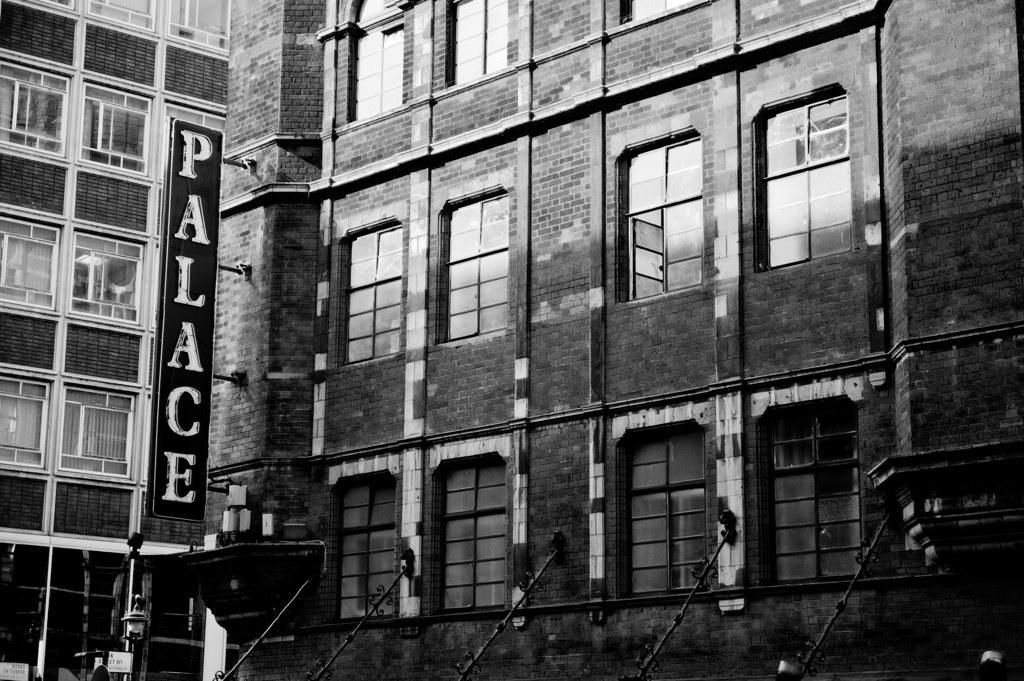What is the color scheme of the image? The image is black and white. What type of structure can be seen in the image? There is a building in the image. Where is the board located in the image? The board is on the left side of the image. How many lizards are crawling on the building in the image? There are no lizards present in the image. What time of day is depicted in the image? The image is black and white, so it is not possible to determine the time of day. 